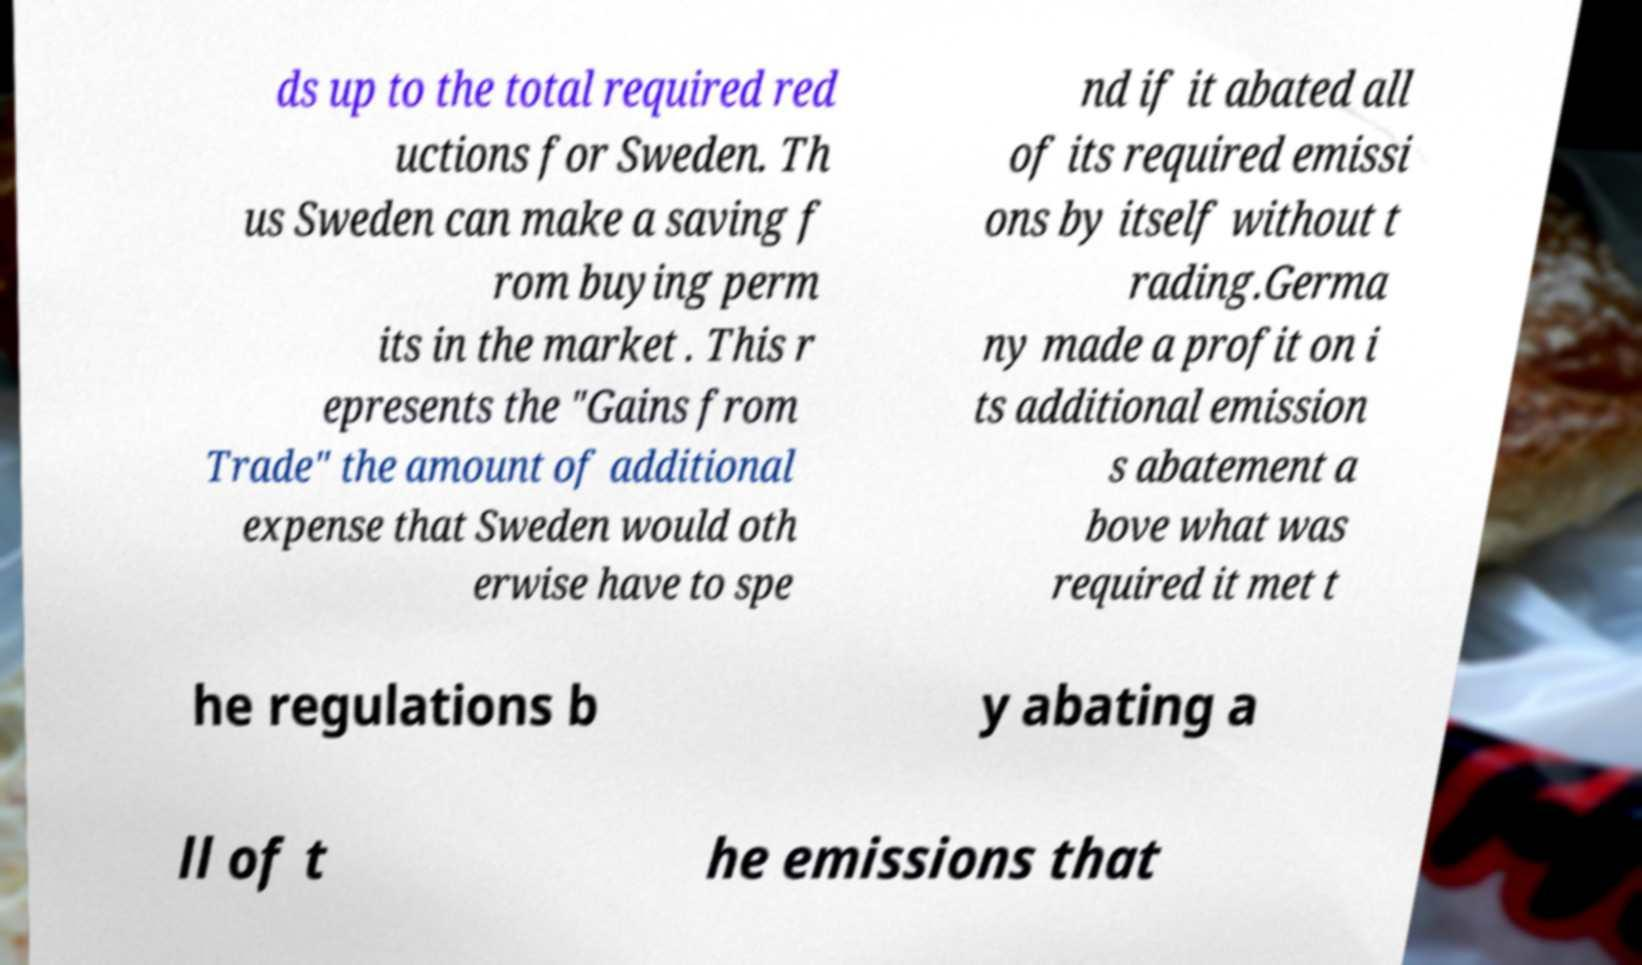There's text embedded in this image that I need extracted. Can you transcribe it verbatim? ds up to the total required red uctions for Sweden. Th us Sweden can make a saving f rom buying perm its in the market . This r epresents the "Gains from Trade" the amount of additional expense that Sweden would oth erwise have to spe nd if it abated all of its required emissi ons by itself without t rading.Germa ny made a profit on i ts additional emission s abatement a bove what was required it met t he regulations b y abating a ll of t he emissions that 